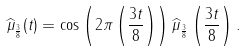Convert formula to latex. <formula><loc_0><loc_0><loc_500><loc_500>\widehat { \mu } _ { \frac { 3 } { 8 } } ( t ) = \cos \left ( 2 \pi \left ( \frac { 3 t } { 8 } \right ) \right ) \widehat { \mu } _ { \frac { 3 } { 8 } } \left ( \frac { 3 t } { 8 } \right ) .</formula> 